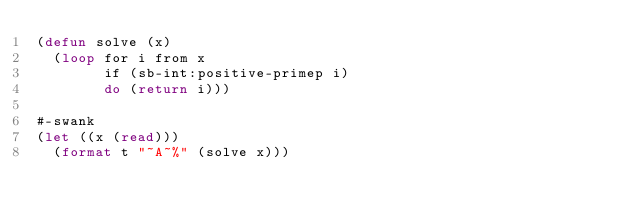<code> <loc_0><loc_0><loc_500><loc_500><_Lisp_>(defun solve (x)
  (loop for i from x
        if (sb-int:positive-primep i)
        do (return i)))

#-swank
(let ((x (read)))
  (format t "~A~%" (solve x)))
</code> 